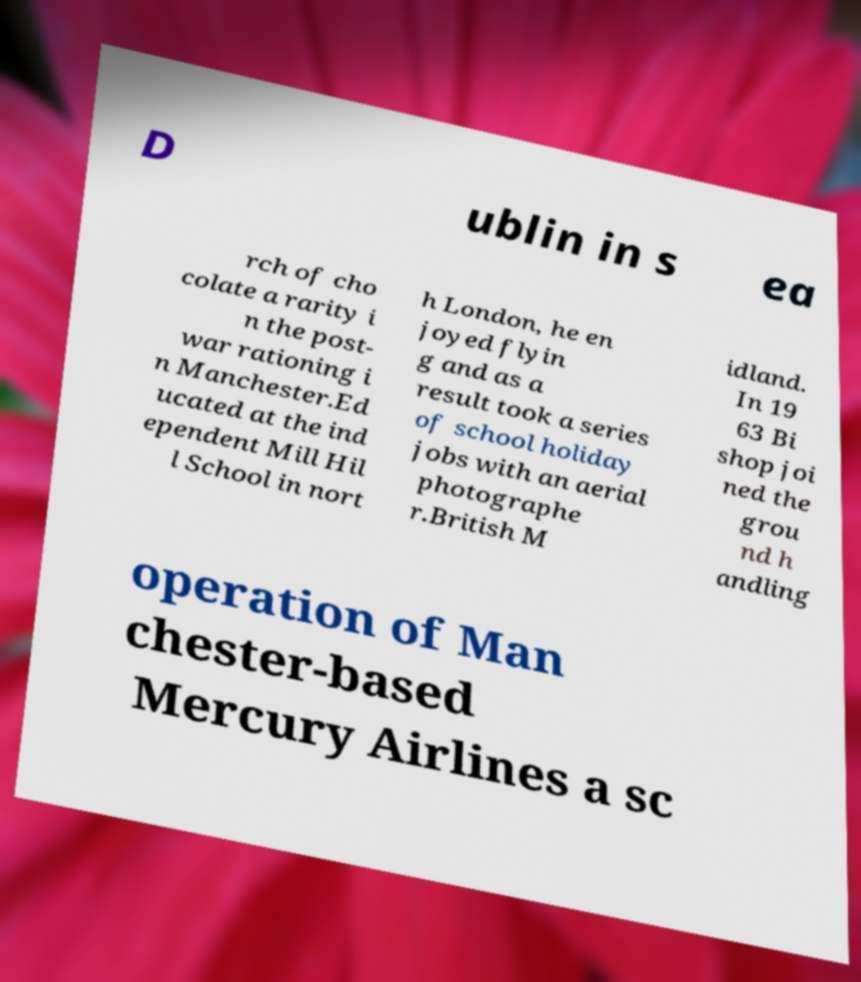Could you assist in decoding the text presented in this image and type it out clearly? D ublin in s ea rch of cho colate a rarity i n the post- war rationing i n Manchester.Ed ucated at the ind ependent Mill Hil l School in nort h London, he en joyed flyin g and as a result took a series of school holiday jobs with an aerial photographe r.British M idland. In 19 63 Bi shop joi ned the grou nd h andling operation of Man chester-based Mercury Airlines a sc 